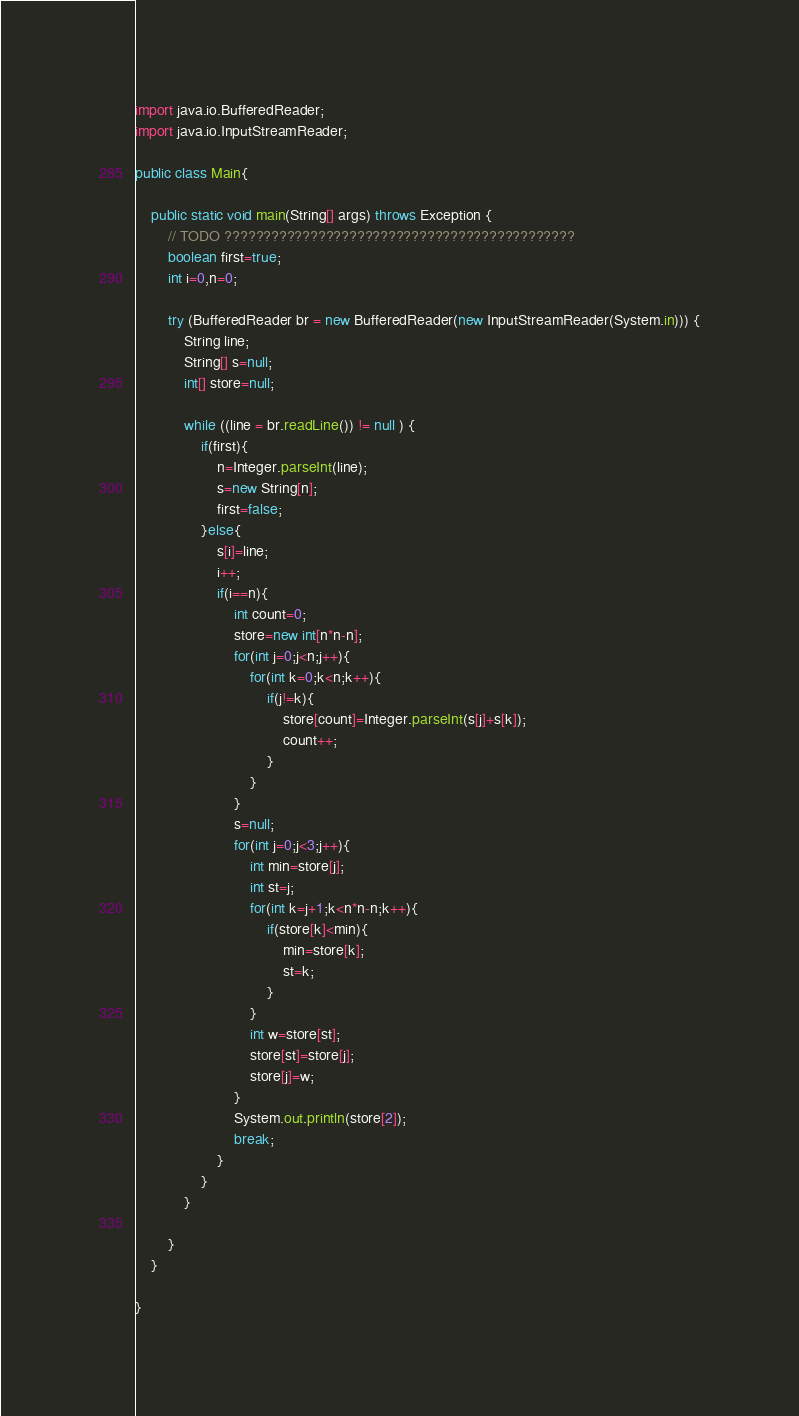<code> <loc_0><loc_0><loc_500><loc_500><_Java_>import java.io.BufferedReader;
import java.io.InputStreamReader;

public class Main{

	public static void main(String[] args) throws Exception {
		// TODO ?????????????????????????????????????????????
		boolean first=true;
		int i=0,n=0;

		try (BufferedReader br = new BufferedReader(new InputStreamReader(System.in))) {
            String line;
            String[] s=null;
            int[] store=null;

            while ((line = br.readLine()) != null ) {
            	if(first){
            		n=Integer.parseInt(line);
            		s=new String[n];
            		first=false;
            	}else{
            		s[i]=line;
            		i++;
            		if(i==n){
            			int count=0;
            			store=new int[n*n-n];
            			for(int j=0;j<n;j++){
            				for(int k=0;k<n;k++){
            					if(j!=k){
            						store[count]=Integer.parseInt(s[j]+s[k]);
            						count++;
            					}
                			}
            			}
            			s=null;
            			for(int j=0;j<3;j++){
            				int min=store[j];
            				int st=j;
            				for(int k=j+1;k<n*n-n;k++){
            					if(store[k]<min){
            						min=store[k];
            						st=k;
            					}
                			}
            				int w=store[st];
            				store[st]=store[j];
            				store[j]=w;
            			}
            			System.out.println(store[2]);
            			break;
            		}
            	}
            }

		}
	}

}</code> 